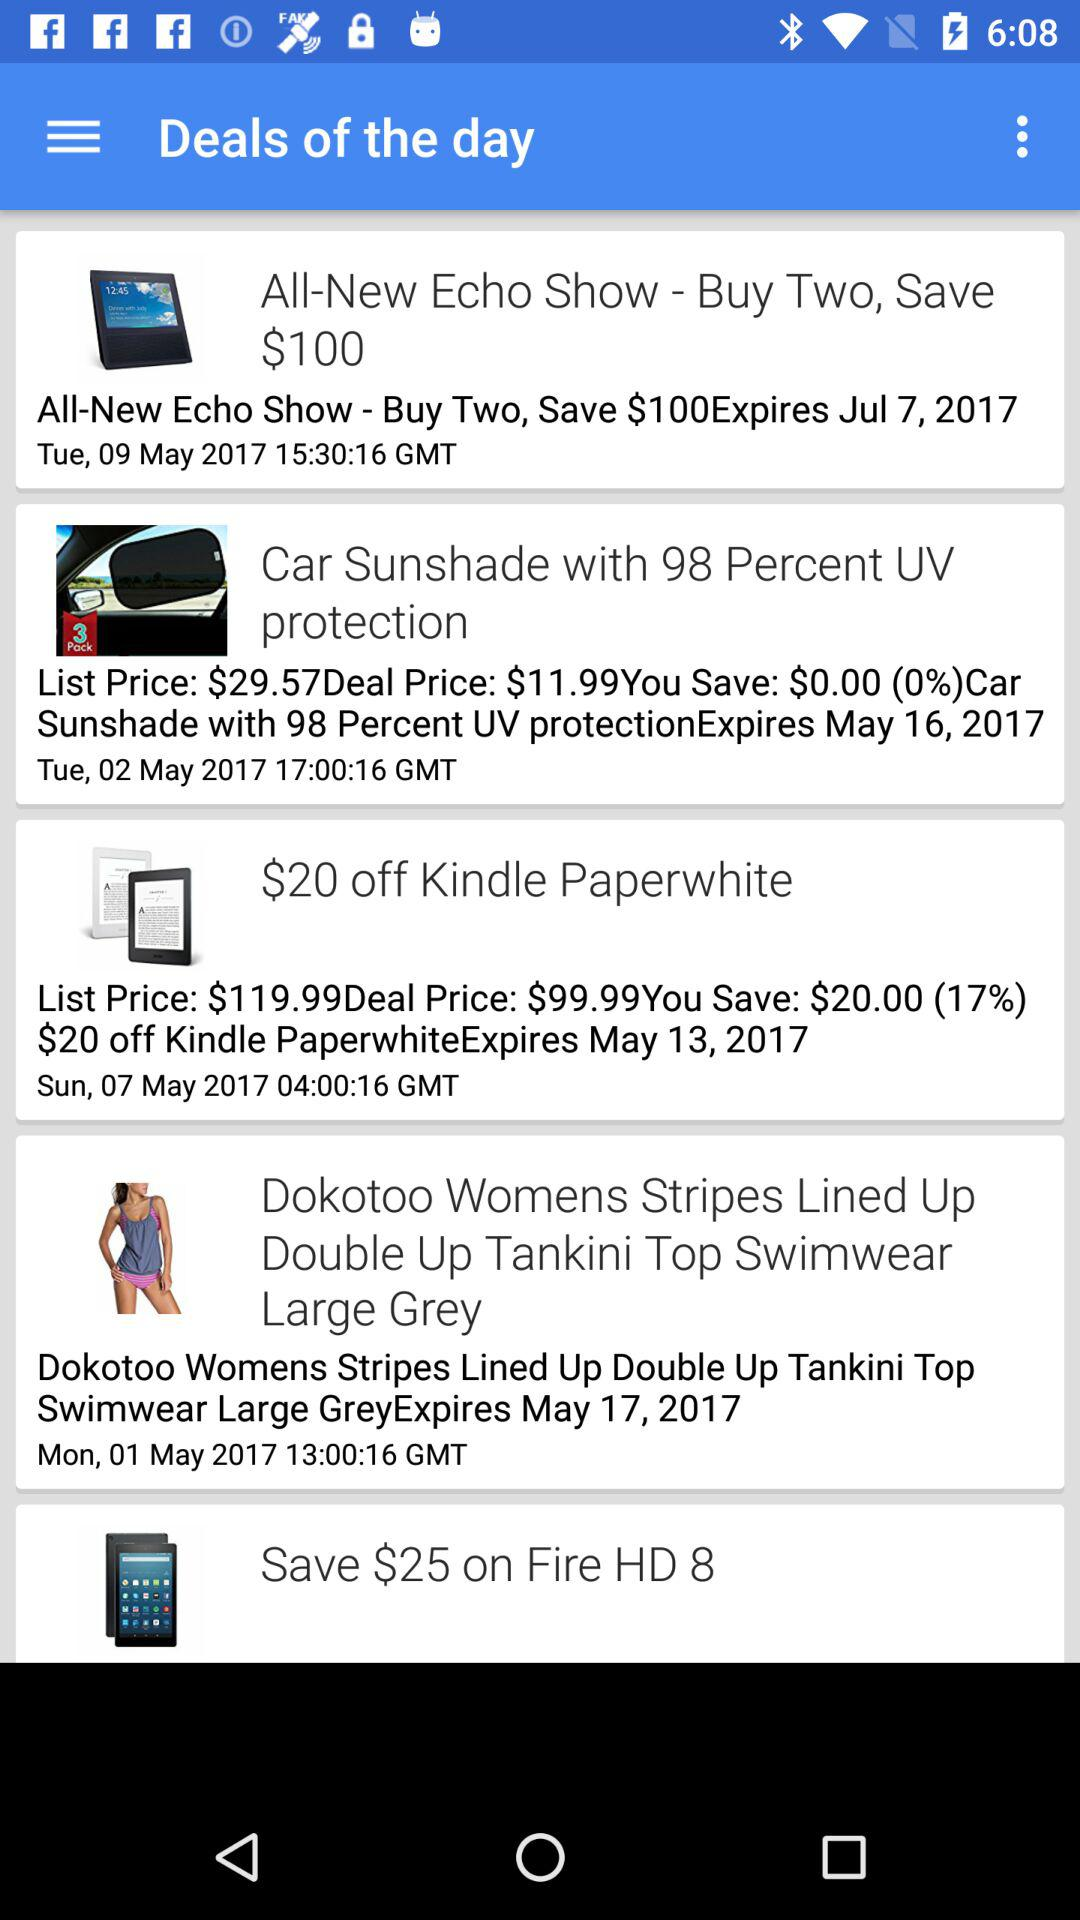How many deals are there?
Answer the question using a single word or phrase. 5 